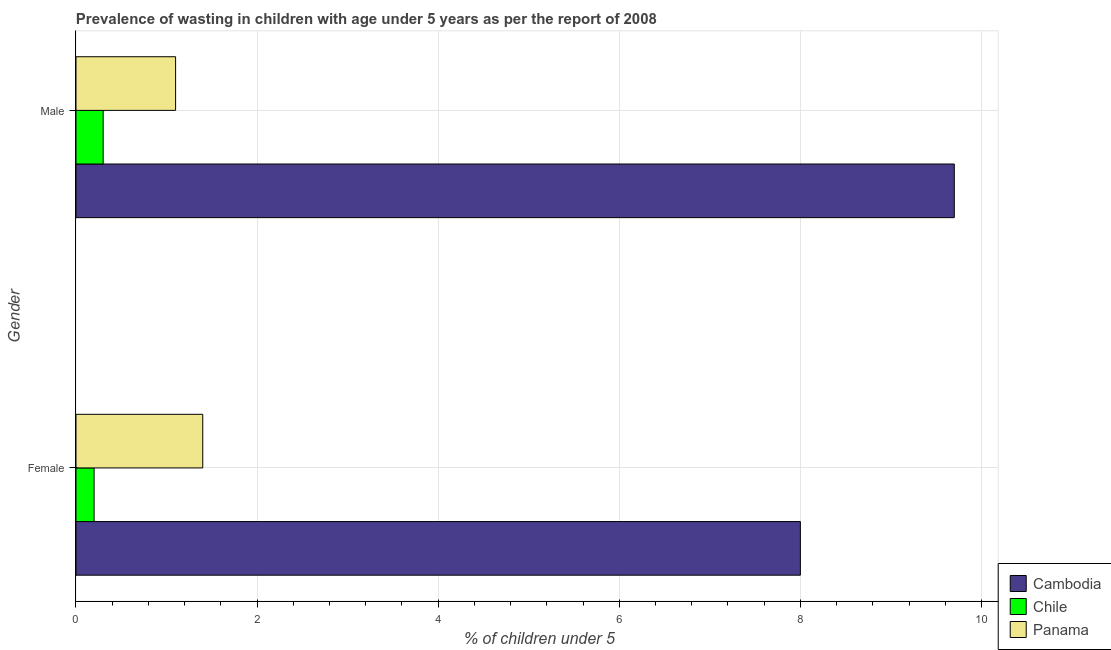Are the number of bars on each tick of the Y-axis equal?
Your answer should be very brief. Yes. How many bars are there on the 2nd tick from the bottom?
Provide a short and direct response. 3. What is the percentage of undernourished male children in Chile?
Make the answer very short. 0.3. Across all countries, what is the maximum percentage of undernourished male children?
Make the answer very short. 9.7. Across all countries, what is the minimum percentage of undernourished female children?
Your answer should be compact. 0.2. In which country was the percentage of undernourished male children maximum?
Give a very brief answer. Cambodia. In which country was the percentage of undernourished female children minimum?
Provide a short and direct response. Chile. What is the total percentage of undernourished male children in the graph?
Ensure brevity in your answer.  11.1. What is the difference between the percentage of undernourished female children in Cambodia and that in Panama?
Offer a terse response. 6.6. What is the difference between the percentage of undernourished male children in Cambodia and the percentage of undernourished female children in Chile?
Provide a succinct answer. 9.5. What is the average percentage of undernourished female children per country?
Provide a short and direct response. 3.2. What is the difference between the percentage of undernourished female children and percentage of undernourished male children in Panama?
Provide a succinct answer. 0.3. What is the ratio of the percentage of undernourished male children in Panama to that in Cambodia?
Your response must be concise. 0.11. In how many countries, is the percentage of undernourished female children greater than the average percentage of undernourished female children taken over all countries?
Give a very brief answer. 1. What does the 2nd bar from the top in Male represents?
Ensure brevity in your answer.  Chile. What does the 2nd bar from the bottom in Female represents?
Your response must be concise. Chile. Are all the bars in the graph horizontal?
Make the answer very short. Yes. How many countries are there in the graph?
Keep it short and to the point. 3. What is the difference between two consecutive major ticks on the X-axis?
Ensure brevity in your answer.  2. Are the values on the major ticks of X-axis written in scientific E-notation?
Make the answer very short. No. Where does the legend appear in the graph?
Provide a short and direct response. Bottom right. How many legend labels are there?
Offer a terse response. 3. What is the title of the graph?
Give a very brief answer. Prevalence of wasting in children with age under 5 years as per the report of 2008. Does "Congo (Democratic)" appear as one of the legend labels in the graph?
Offer a terse response. No. What is the label or title of the X-axis?
Offer a terse response.  % of children under 5. What is the  % of children under 5 in Cambodia in Female?
Your answer should be compact. 8. What is the  % of children under 5 in Chile in Female?
Offer a terse response. 0.2. What is the  % of children under 5 in Panama in Female?
Provide a succinct answer. 1.4. What is the  % of children under 5 in Cambodia in Male?
Your answer should be very brief. 9.7. What is the  % of children under 5 in Chile in Male?
Provide a succinct answer. 0.3. What is the  % of children under 5 in Panama in Male?
Your answer should be compact. 1.1. Across all Gender, what is the maximum  % of children under 5 of Cambodia?
Ensure brevity in your answer.  9.7. Across all Gender, what is the maximum  % of children under 5 of Chile?
Make the answer very short. 0.3. Across all Gender, what is the maximum  % of children under 5 in Panama?
Your answer should be very brief. 1.4. Across all Gender, what is the minimum  % of children under 5 of Chile?
Your response must be concise. 0.2. Across all Gender, what is the minimum  % of children under 5 of Panama?
Provide a short and direct response. 1.1. What is the total  % of children under 5 in Panama in the graph?
Keep it short and to the point. 2.5. What is the difference between the  % of children under 5 in Chile in Female and that in Male?
Keep it short and to the point. -0.1. What is the difference between the  % of children under 5 of Panama in Female and that in Male?
Your answer should be compact. 0.3. What is the difference between the  % of children under 5 of Cambodia in Female and the  % of children under 5 of Chile in Male?
Ensure brevity in your answer.  7.7. What is the average  % of children under 5 in Cambodia per Gender?
Offer a very short reply. 8.85. What is the average  % of children under 5 in Panama per Gender?
Your answer should be compact. 1.25. What is the difference between the  % of children under 5 of Cambodia and  % of children under 5 of Panama in Female?
Make the answer very short. 6.6. What is the difference between the  % of children under 5 of Cambodia and  % of children under 5 of Chile in Male?
Your answer should be very brief. 9.4. What is the ratio of the  % of children under 5 of Cambodia in Female to that in Male?
Provide a succinct answer. 0.82. What is the ratio of the  % of children under 5 in Panama in Female to that in Male?
Your answer should be compact. 1.27. What is the difference between the highest and the second highest  % of children under 5 in Cambodia?
Offer a very short reply. 1.7. What is the difference between the highest and the second highest  % of children under 5 in Panama?
Keep it short and to the point. 0.3. What is the difference between the highest and the lowest  % of children under 5 of Chile?
Your answer should be very brief. 0.1. 